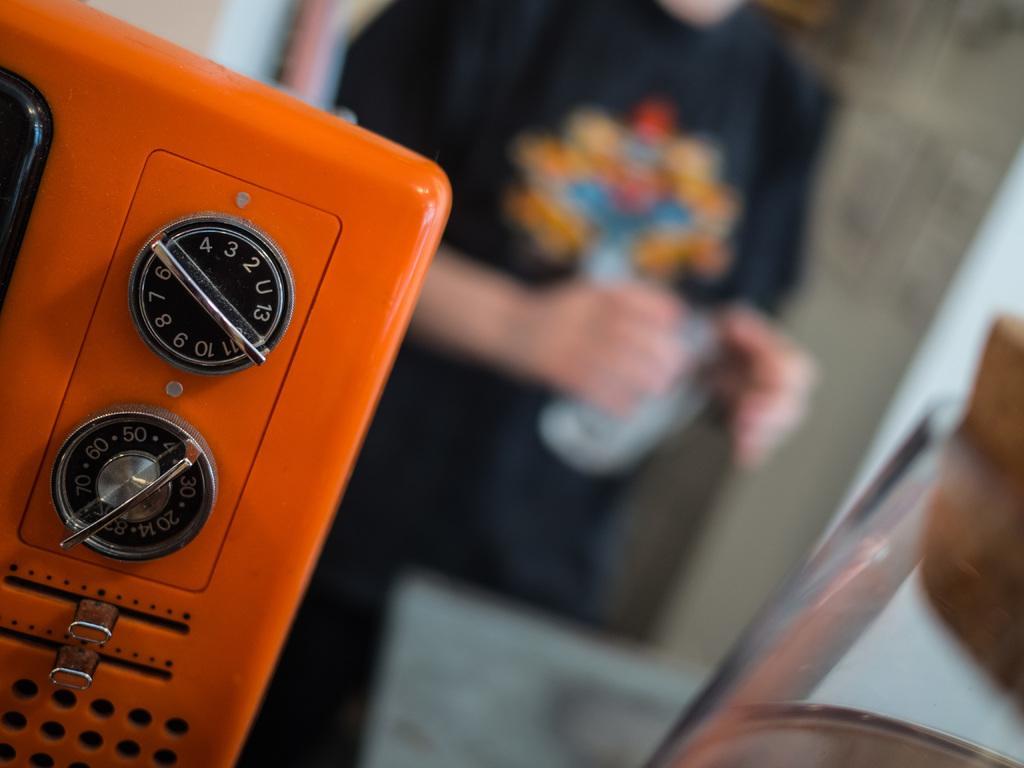Please provide a concise description of this image. There is an electronic device with some knobs. In the background it is blurred. Also there is a person standing. 